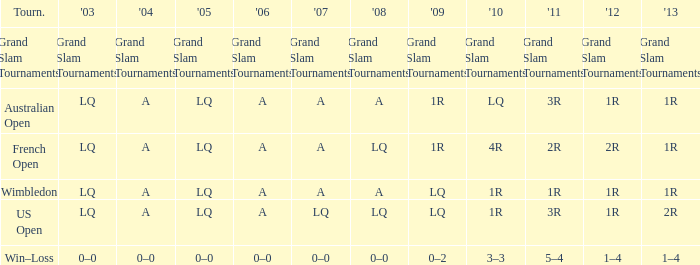Could you help me parse every detail presented in this table? {'header': ['Tourn.', "'03", "'04", "'05", "'06", "'07", "'08", "'09", "'10", "'11", "'12", "'13"], 'rows': [['Grand Slam Tournaments', 'Grand Slam Tournaments', 'Grand Slam Tournaments', 'Grand Slam Tournaments', 'Grand Slam Tournaments', 'Grand Slam Tournaments', 'Grand Slam Tournaments', 'Grand Slam Tournaments', 'Grand Slam Tournaments', 'Grand Slam Tournaments', 'Grand Slam Tournaments', 'Grand Slam Tournaments'], ['Australian Open', 'LQ', 'A', 'LQ', 'A', 'A', 'A', '1R', 'LQ', '3R', '1R', '1R'], ['French Open', 'LQ', 'A', 'LQ', 'A', 'A', 'LQ', '1R', '4R', '2R', '2R', '1R'], ['Wimbledon', 'LQ', 'A', 'LQ', 'A', 'A', 'A', 'LQ', '1R', '1R', '1R', '1R'], ['US Open', 'LQ', 'A', 'LQ', 'A', 'LQ', 'LQ', 'LQ', '1R', '3R', '1R', '2R'], ['Win–Loss', '0–0', '0–0', '0–0', '0–0', '0–0', '0–0', '0–2', '3–3', '5–4', '1–4', '1–4']]} Which tournament has a 2013 of 1r, and a 2012 of 1r? Australian Open, Wimbledon. 